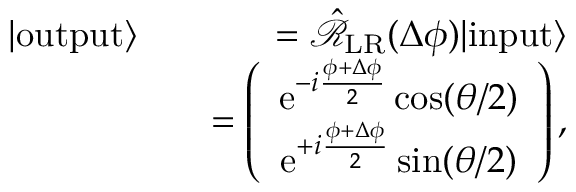<formula> <loc_0><loc_0><loc_500><loc_500>\begin{array} { r l r } { | o u t p u t \rangle } & { = \hat { \mathcal { R } } _ { L R } ( \Delta \phi ) | i n p u t \rangle } \\ & { = \left ( \begin{array} { c } { e ^ { - i \frac { \phi + \Delta \phi } { 2 } } \cos ( \theta / 2 ) } \\ { e ^ { + i \frac { \phi + \Delta \phi } { 2 } } \sin ( \theta / 2 ) } \end{array} \right ) , } \end{array}</formula> 